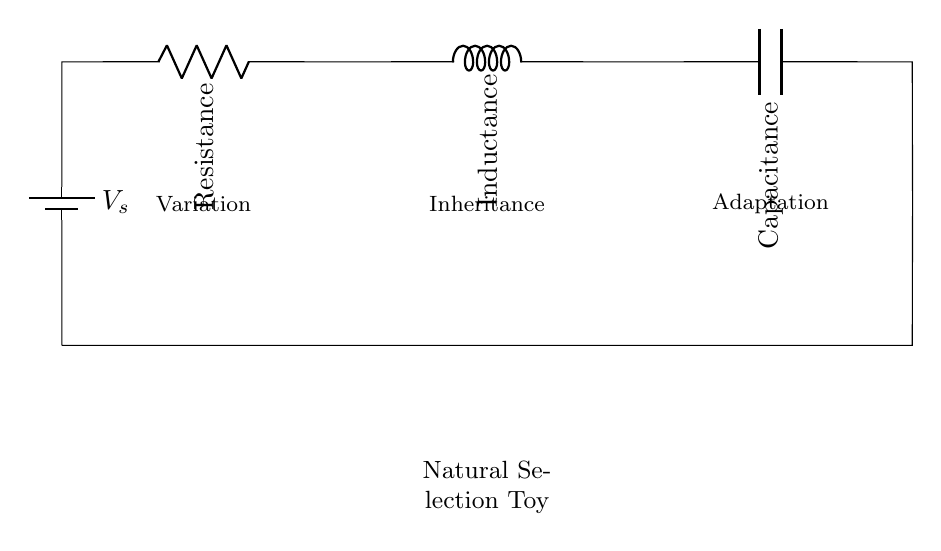What components are in this circuit? The circuit contains a battery, a resistor, an inductor, and a capacitor, as indicated by their labels in the diagram.
Answer: Battery, resistor, inductor, capacitor What is the function of the resistor in this circuit? The resistor limits the flow of current, which helps control the energy in the circuit, making sure it does not become too high.
Answer: Current limiting Which component represents 'variation' in the context of natural selection? The term 'variation' is labeled near the resistor, suggesting that it represents the differences in traits among individuals in a population.
Answer: Resistor What does the inductor do in this circuit? The inductor stores energy in a magnetic field when current flows through it and releases it when the current decreases, similar to how certain traits may be passed on over generations.
Answer: Energy storage How does 'adaptation' apply to this circuit? The concept of 'adaptation' is linked to the capacitor in the diagram, indicating how energy storage can change circuit behavior, much like how organisms adapt to their environment.
Answer: Capacitor's function What is the connection between components in this circuit? The circuit shows a series connection; starting from the battery, current flows through the resistor, then the inductor, then the capacitor, returning to the battery.
Answer: Series connection 